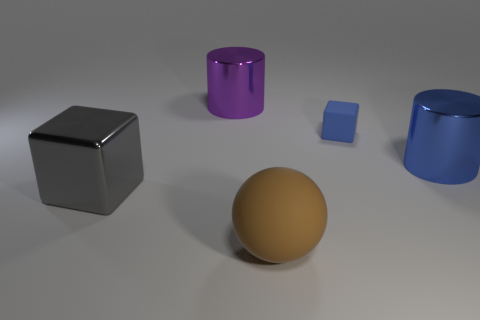Add 1 small blue things. How many objects exist? 6 Subtract all blocks. How many objects are left? 3 Add 4 small cubes. How many small cubes are left? 5 Add 1 purple metallic objects. How many purple metallic objects exist? 2 Subtract 0 green cubes. How many objects are left? 5 Subtract all red blocks. Subtract all blue cubes. How many objects are left? 4 